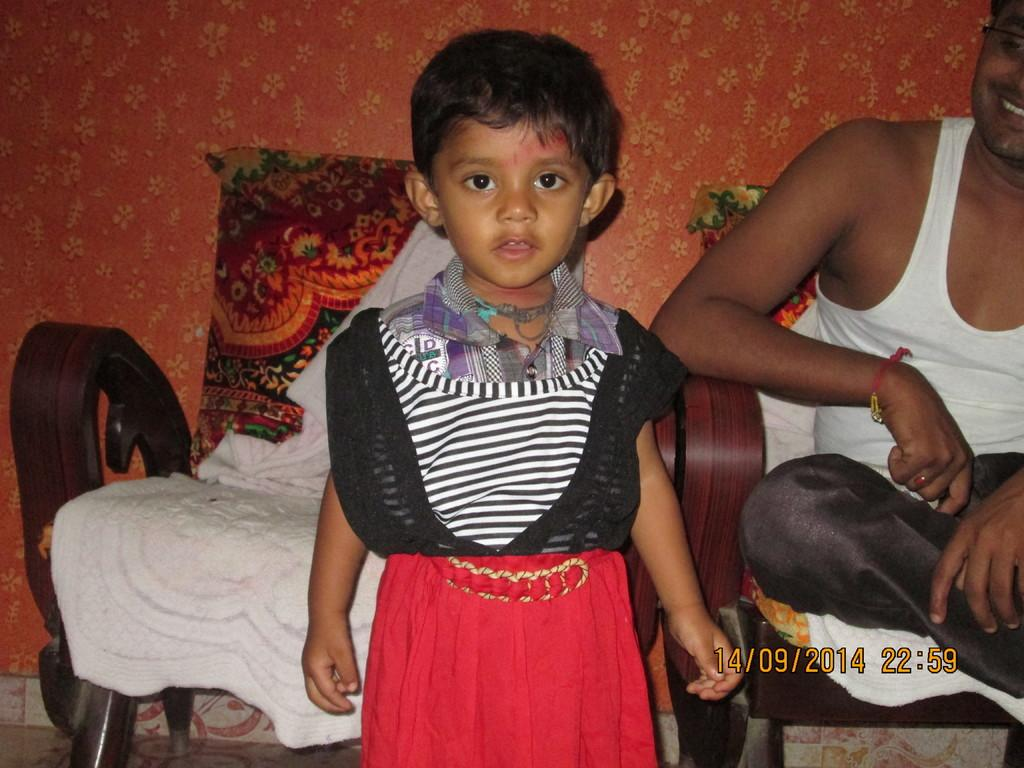How many people are in the image? There are two persons in the image. Can you describe the individuals in the image? One person is a man, and the other person is a girl. What is the man doing in the image? The man is sitting on a chair. What is the girl doing in the image? The girl is standing. What color is the background of the image? The background of the image is orange. Can you see the girl kicking a ball in the image? There is no ball present in the image, and the girl is not kicking anything. 